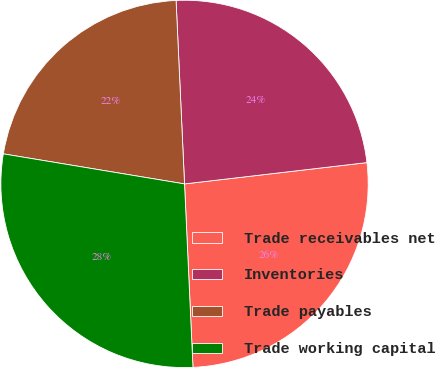<chart> <loc_0><loc_0><loc_500><loc_500><pie_chart><fcel>Trade receivables net<fcel>Inventories<fcel>Trade payables<fcel>Trade working capital<nl><fcel>26.12%<fcel>23.88%<fcel>21.65%<fcel>28.35%<nl></chart> 